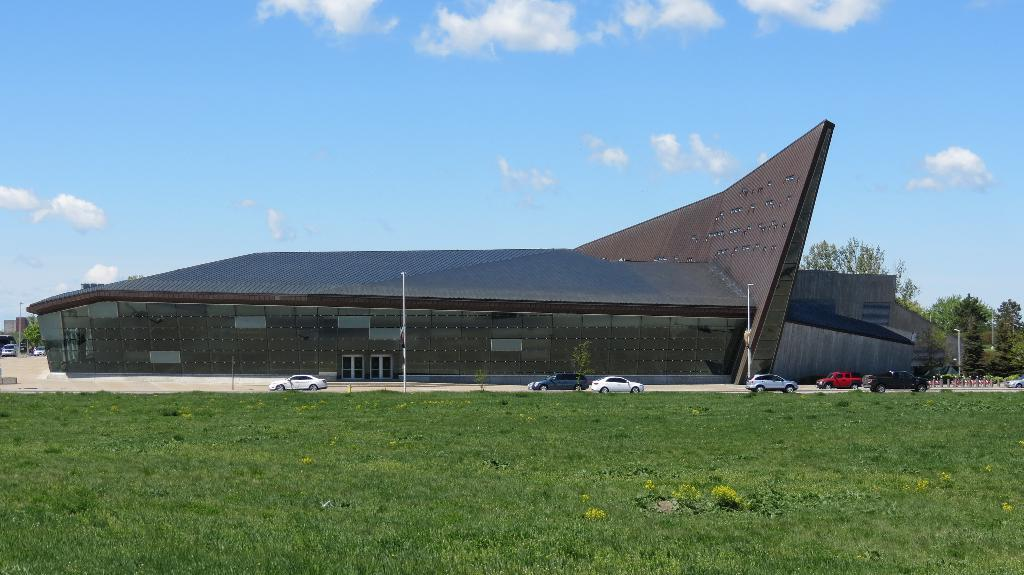What is the main subject in the center of the image? There is a building in the center of the image. What type of vehicles can be seen in the image? Cars are visible in the image. What are the tall, thin structures in the image? There are poles in the image. What type of vegetation is present at the bottom of the image? Grass is present at the bottom of the image. What can be seen in the background of the image? There are trees and the sky visible in the background of the image. What type of stitch is being used to sew the birthday cake in the image? There is no birthday cake or stitching present in the image. 